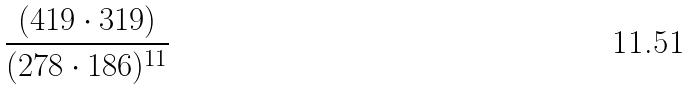Convert formula to latex. <formula><loc_0><loc_0><loc_500><loc_500>\frac { ( 4 1 9 \cdot 3 1 9 ) } { ( 2 7 8 \cdot 1 8 6 ) ^ { 1 1 } }</formula> 